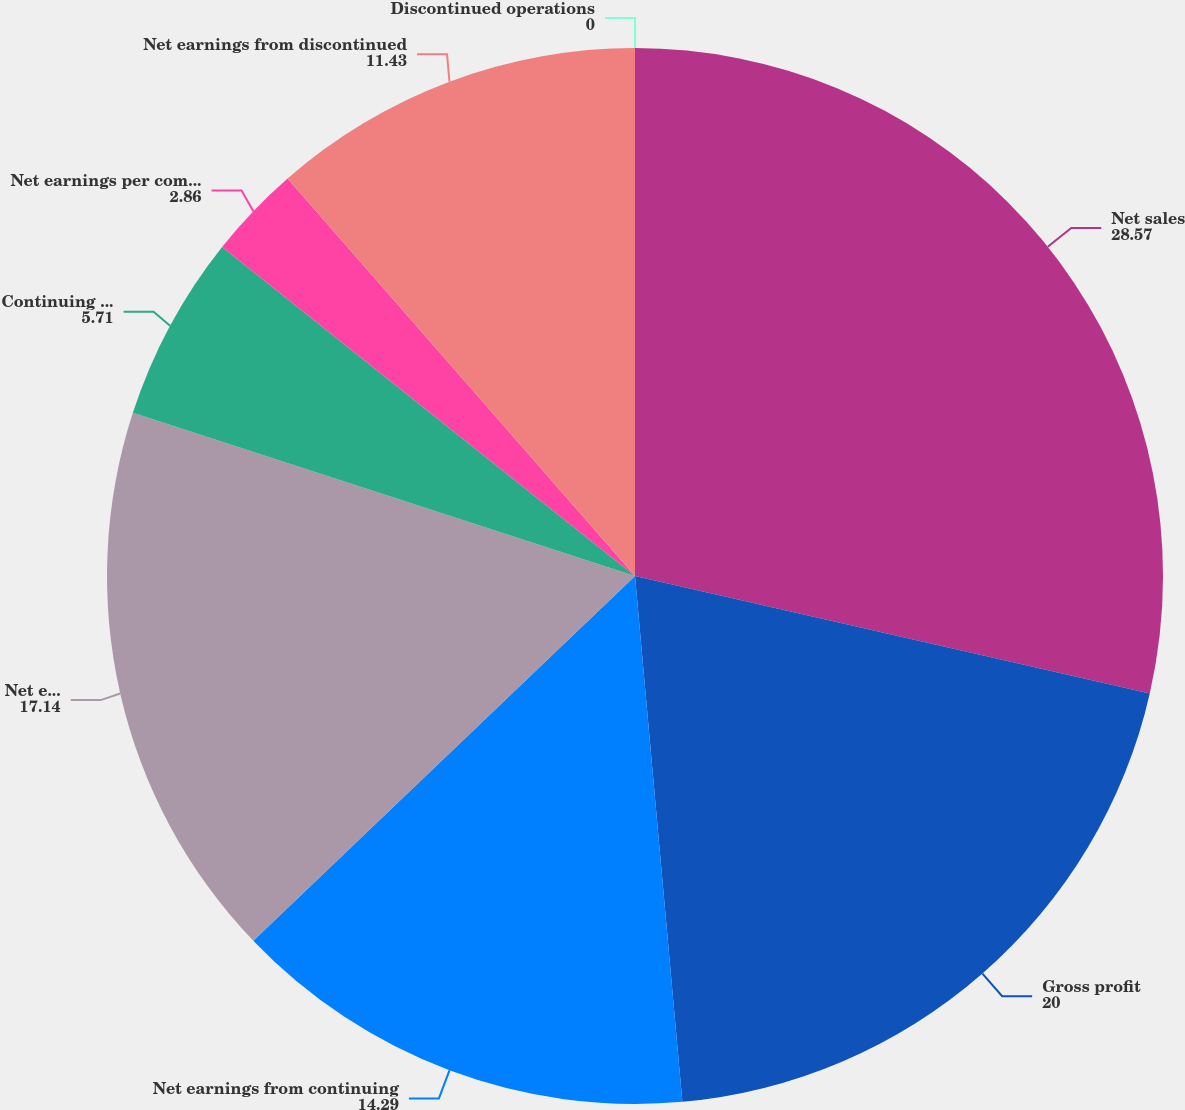Convert chart. <chart><loc_0><loc_0><loc_500><loc_500><pie_chart><fcel>Net sales<fcel>Gross profit<fcel>Net earnings from continuing<fcel>Net earnings available to<fcel>Continuing operations<fcel>Net earnings per common<fcel>Net earnings from discontinued<fcel>Discontinued operations<nl><fcel>28.57%<fcel>20.0%<fcel>14.29%<fcel>17.14%<fcel>5.71%<fcel>2.86%<fcel>11.43%<fcel>0.0%<nl></chart> 